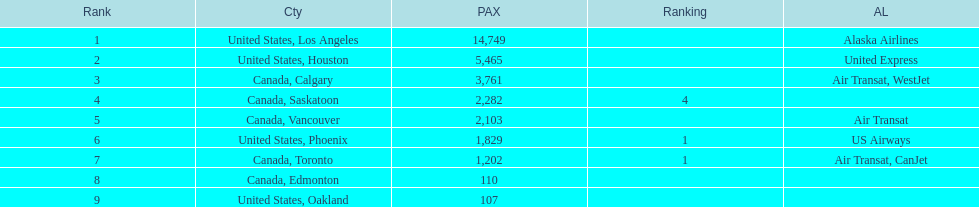Which airline carries the most passengers? Alaska Airlines. 